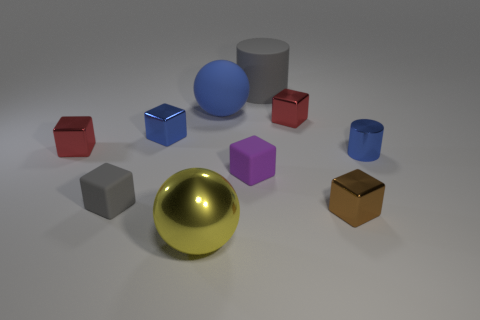Is there a red thing?
Make the answer very short. Yes. Is there any other thing that has the same color as the big metallic ball?
Your answer should be compact. No. There is another small object that is made of the same material as the tiny purple object; what is its shape?
Provide a short and direct response. Cube. What color is the cylinder that is to the left of the red metal block that is on the right side of the ball behind the tiny gray rubber cube?
Keep it short and to the point. Gray. Is the number of tiny gray blocks to the right of the big yellow shiny sphere the same as the number of big gray rubber objects?
Provide a succinct answer. No. Are there any other things that are made of the same material as the small cylinder?
Provide a succinct answer. Yes. There is a tiny shiny cylinder; does it have the same color as the tiny rubber block that is to the left of the blue cube?
Your response must be concise. No. There is a shiny cube in front of the blue object that is on the right side of the matte cylinder; are there any big spheres in front of it?
Provide a succinct answer. Yes. Are there fewer big blue matte spheres to the left of the blue shiny cube than gray matte cylinders?
Your response must be concise. Yes. How many other things are there of the same shape as the purple rubber object?
Make the answer very short. 5. 